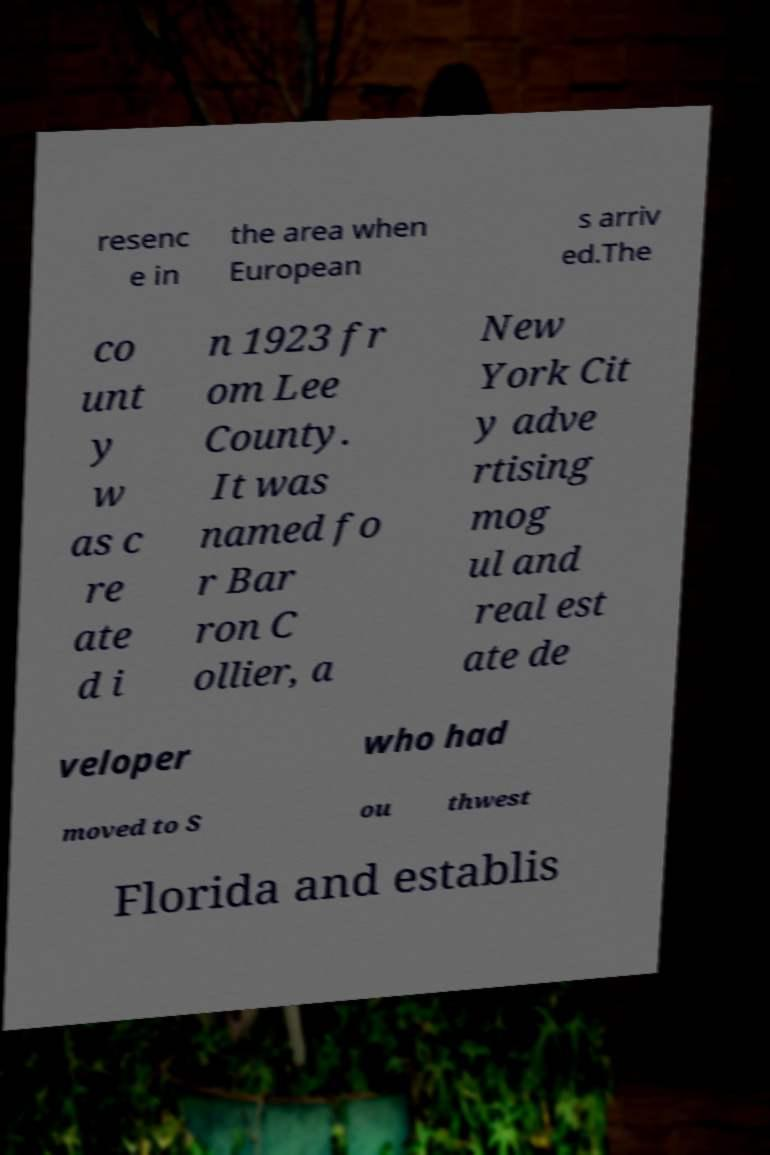For documentation purposes, I need the text within this image transcribed. Could you provide that? resenc e in the area when European s arriv ed.The co unt y w as c re ate d i n 1923 fr om Lee County. It was named fo r Bar ron C ollier, a New York Cit y adve rtising mog ul and real est ate de veloper who had moved to S ou thwest Florida and establis 